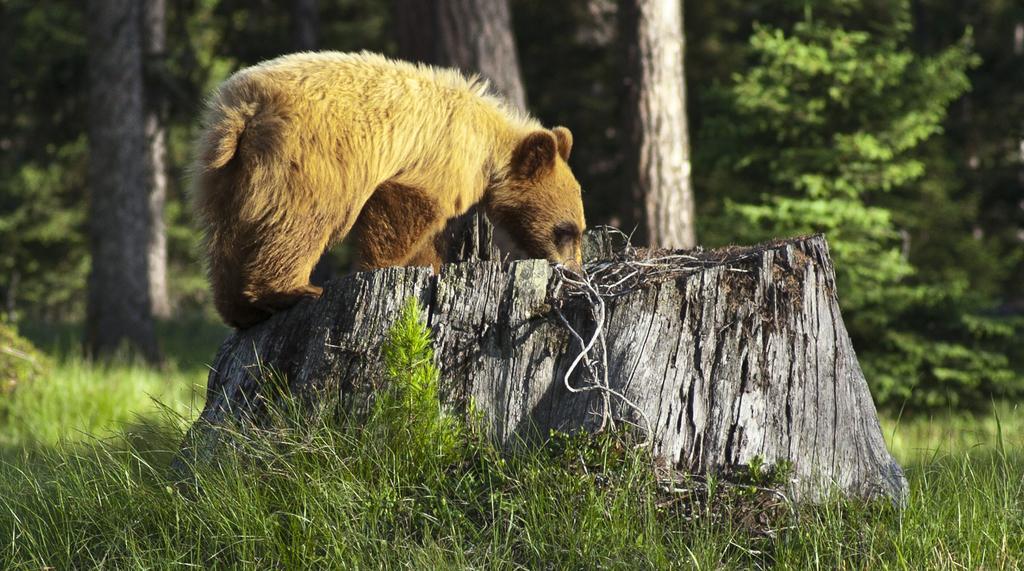Can you describe this image briefly? In this image there is a grassland, in the middle there is a log, on that there is a bear, in the background there are trees. 